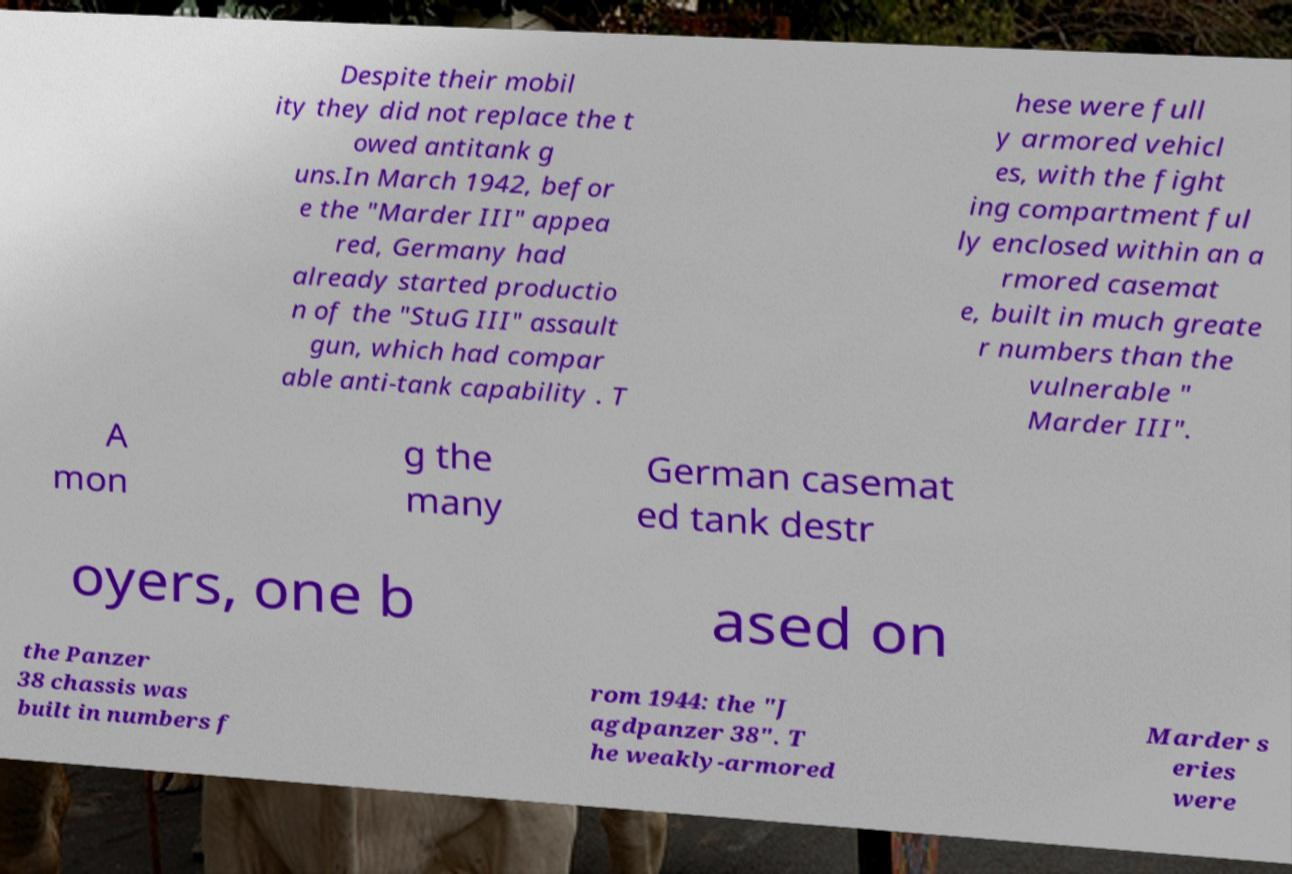Could you extract and type out the text from this image? Despite their mobil ity they did not replace the t owed antitank g uns.In March 1942, befor e the "Marder III" appea red, Germany had already started productio n of the "StuG III" assault gun, which had compar able anti-tank capability . T hese were full y armored vehicl es, with the fight ing compartment ful ly enclosed within an a rmored casemat e, built in much greate r numbers than the vulnerable " Marder III". A mon g the many German casemat ed tank destr oyers, one b ased on the Panzer 38 chassis was built in numbers f rom 1944: the "J agdpanzer 38". T he weakly-armored Marder s eries were 